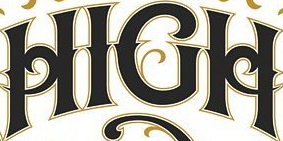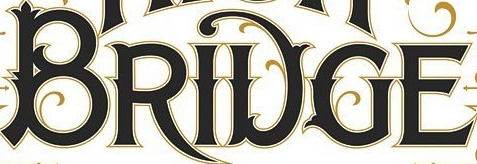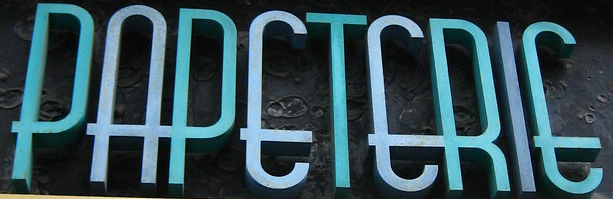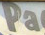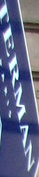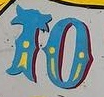Read the text from these images in sequence, separated by a semicolon. HIGH; BRIDGE; PAPETERIE; Pa; TERMAN; TO 